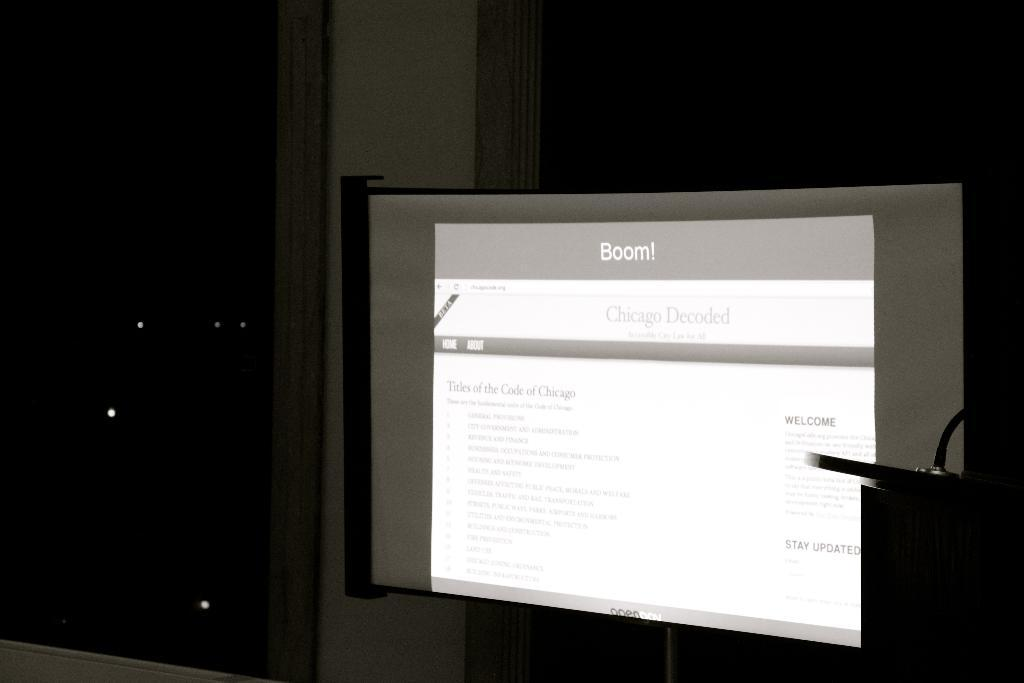<image>
Render a clear and concise summary of the photo. A slide projection on a screen entitled "Boom!" 